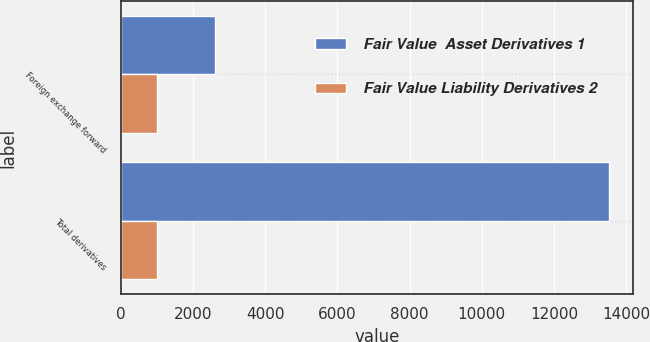Convert chart to OTSL. <chart><loc_0><loc_0><loc_500><loc_500><stacked_bar_chart><ecel><fcel>Foreign exchange forward<fcel>Total derivatives<nl><fcel>Fair Value  Asset Derivatives 1<fcel>2616<fcel>13513<nl><fcel>Fair Value Liability Derivatives 2<fcel>998<fcel>998<nl></chart> 